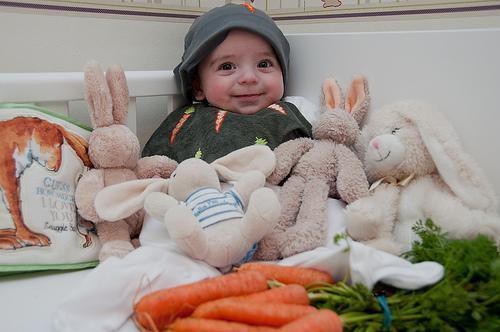How many bunnies are wearing a shirt?
Give a very brief answer. 1. 